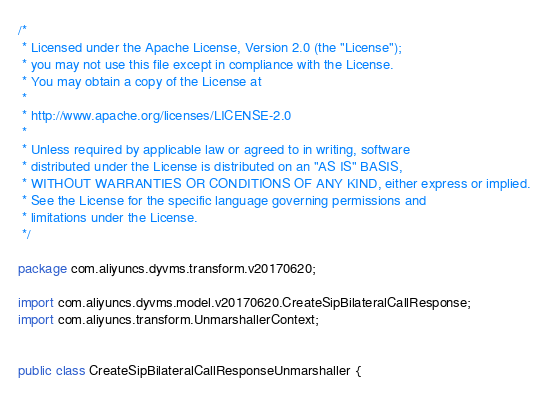<code> <loc_0><loc_0><loc_500><loc_500><_Java_>/*
 * Licensed under the Apache License, Version 2.0 (the "License");
 * you may not use this file except in compliance with the License.
 * You may obtain a copy of the License at
 *
 * http://www.apache.org/licenses/LICENSE-2.0
 *
 * Unless required by applicable law or agreed to in writing, software
 * distributed under the License is distributed on an "AS IS" BASIS,
 * WITHOUT WARRANTIES OR CONDITIONS OF ANY KIND, either express or implied.
 * See the License for the specific language governing permissions and
 * limitations under the License.
 */

package com.aliyuncs.dyvms.transform.v20170620;

import com.aliyuncs.dyvms.model.v20170620.CreateSipBilateralCallResponse;
import com.aliyuncs.transform.UnmarshallerContext;


public class CreateSipBilateralCallResponseUnmarshaller {
</code> 